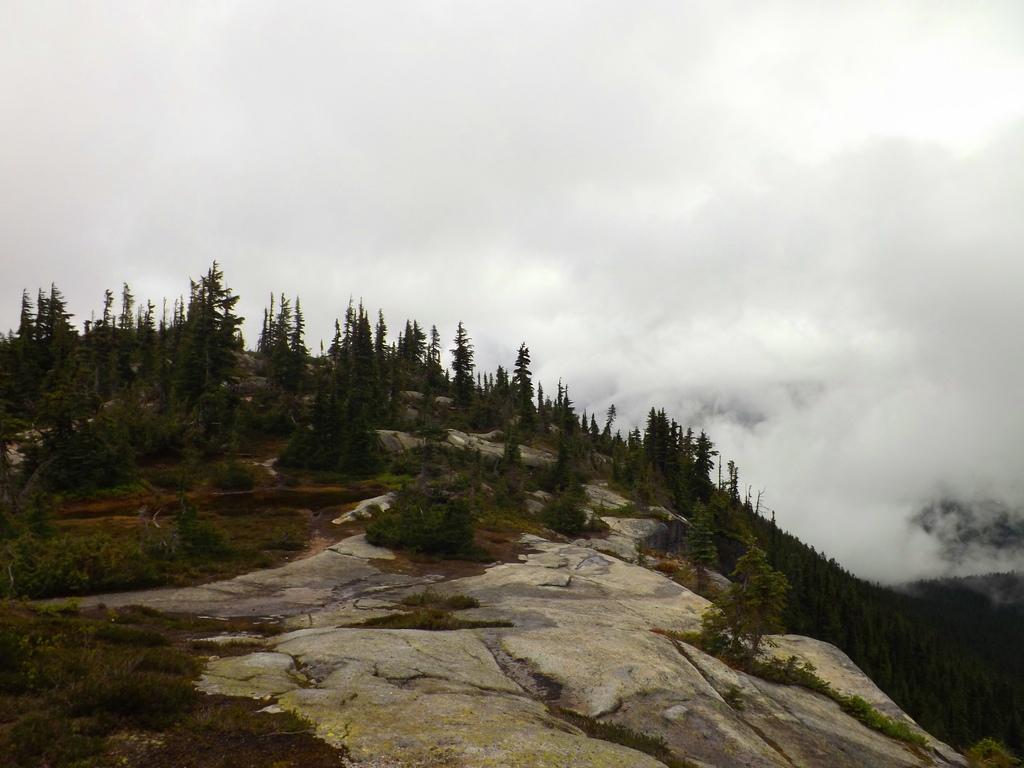Please provide a concise description of this image. We can see rocks,grass and plants on the ground. In the background there are trees,smoke and sky. 